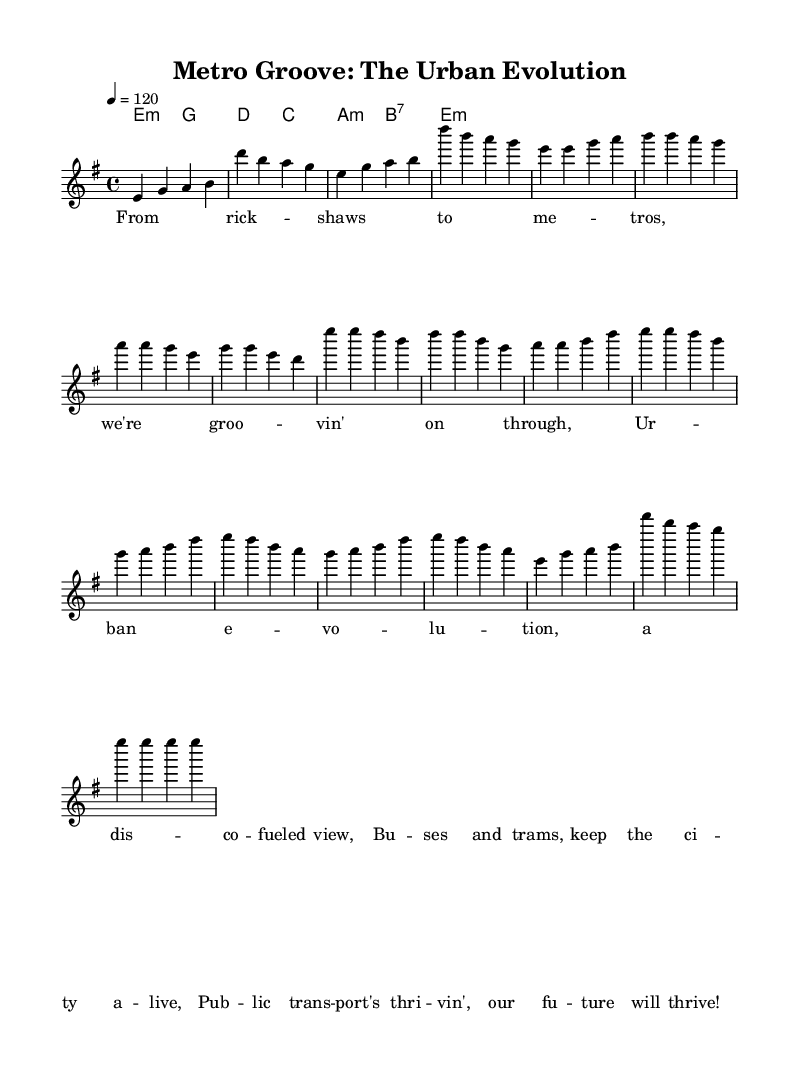What is the key signature of this music? The key signature is E minor, which is indicated by one sharp (F#) in the key signature.
Answer: E minor What is the time signature of the piece? The time signature is 4/4, which is shown at the beginning of the score indicating that there are four beats in each measure and the quarter note gets one beat.
Answer: 4/4 What is the tempo marking for this piece? The tempo marking indicates that the piece should be played at 120 beats per minute, which is specified as "4 = 120".
Answer: 120 How many measures are in the chorus section? The chorus section consists of four measures, as evidenced by counting the grouped vertical lines in the score labeled "Chorus".
Answer: 4 What musical style does this piece represent? The piece represents disco, as indicated by the title "Metro Groove: The Urban Evolution" and the upbeat rhythm typical of disco music.
Answer: Disco What is the highest note in the melody? The highest note in the melody is D, which can be found in the chorus and bridge sections as indicated by the notated pitches.
Answer: D How many times is the note E played in the outro? In the outro section, the note E is played four times consecutively, as shown in the last portion of the melody.
Answer: 4 